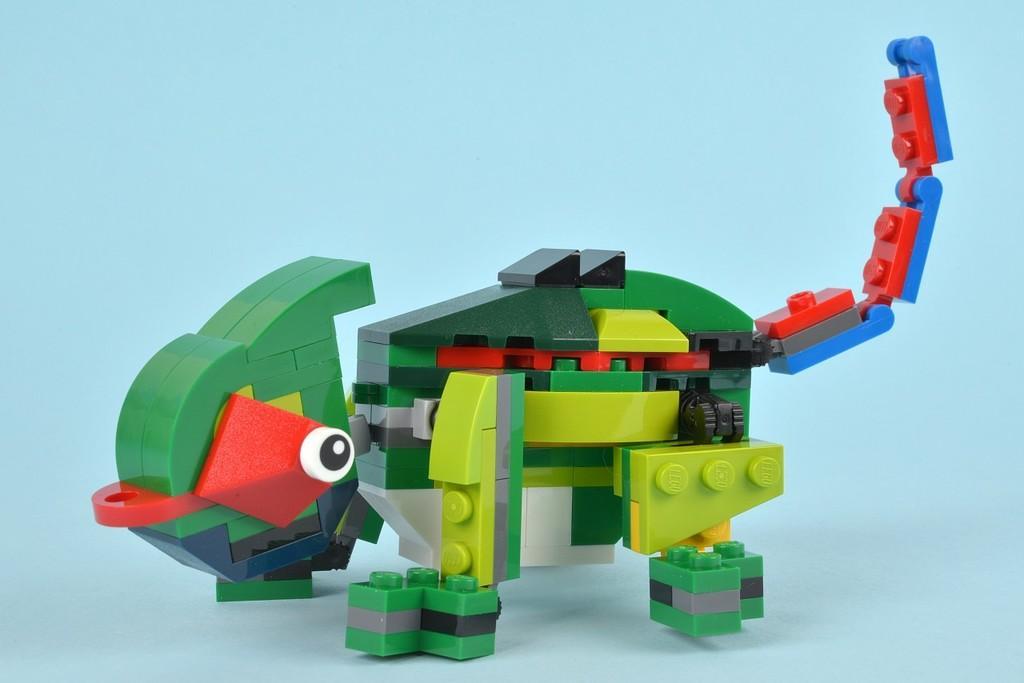How would you summarize this image in a sentence or two? There is a troy bilt with the blocks. 